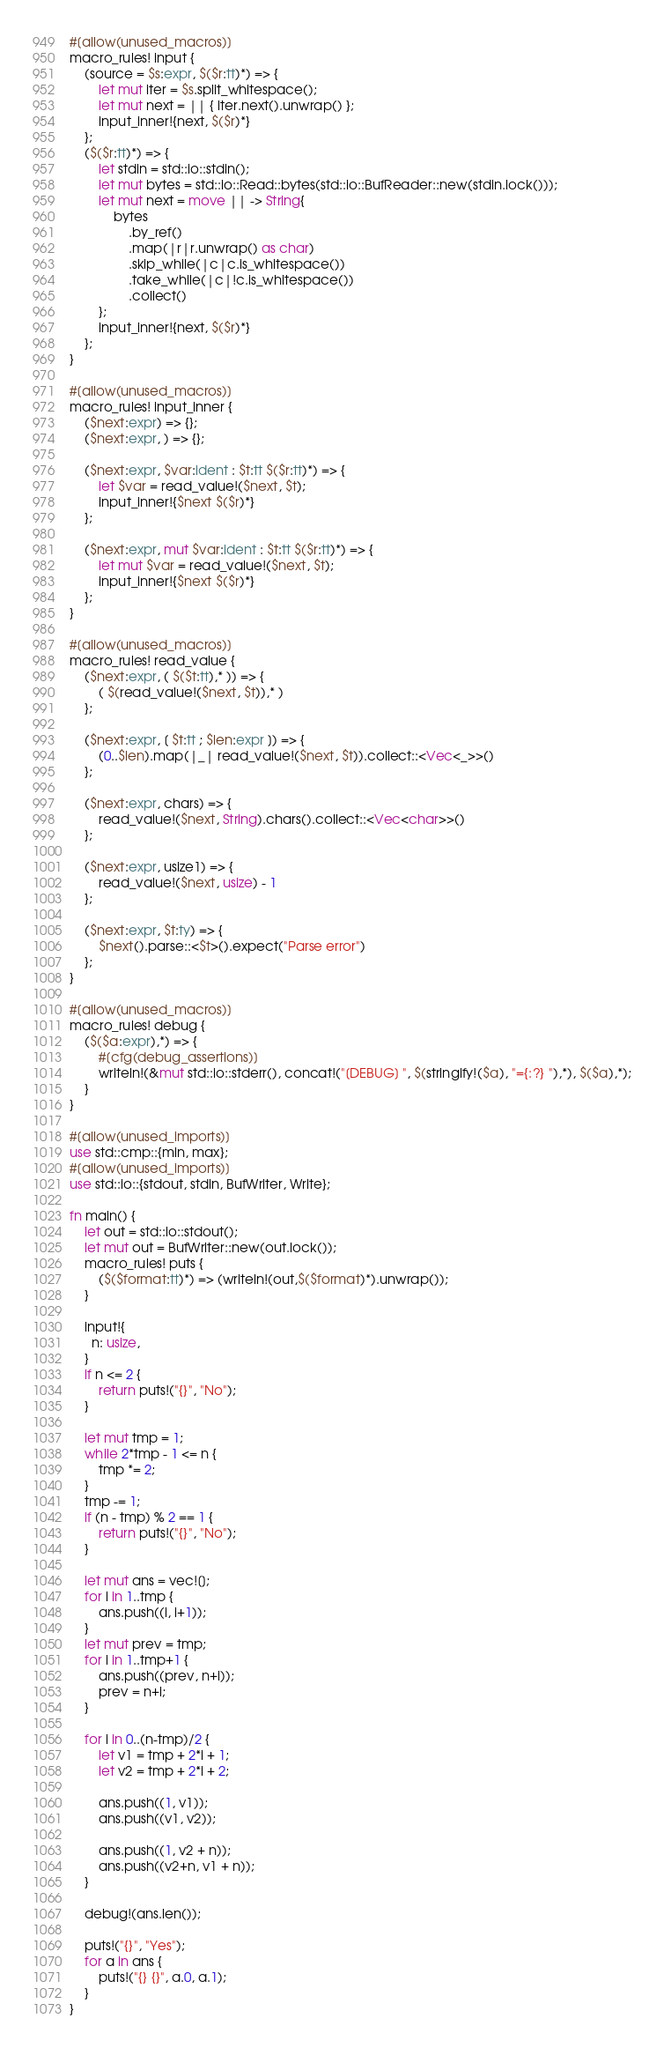<code> <loc_0><loc_0><loc_500><loc_500><_Rust_>#[allow(unused_macros)]
macro_rules! input {
    (source = $s:expr, $($r:tt)*) => {
        let mut iter = $s.split_whitespace();
        let mut next = || { iter.next().unwrap() };
        input_inner!{next, $($r)*}
    };
    ($($r:tt)*) => {
        let stdin = std::io::stdin();
        let mut bytes = std::io::Read::bytes(std::io::BufReader::new(stdin.lock()));
        let mut next = move || -> String{
            bytes
                .by_ref()
                .map(|r|r.unwrap() as char)
                .skip_while(|c|c.is_whitespace())
                .take_while(|c|!c.is_whitespace())
                .collect()
        };
        input_inner!{next, $($r)*}
    };
}

#[allow(unused_macros)]
macro_rules! input_inner {
    ($next:expr) => {};
    ($next:expr, ) => {};

    ($next:expr, $var:ident : $t:tt $($r:tt)*) => {
        let $var = read_value!($next, $t);
        input_inner!{$next $($r)*}
    };

    ($next:expr, mut $var:ident : $t:tt $($r:tt)*) => {
        let mut $var = read_value!($next, $t);
        input_inner!{$next $($r)*}
    };
}

#[allow(unused_macros)]
macro_rules! read_value {
    ($next:expr, ( $($t:tt),* )) => {
        ( $(read_value!($next, $t)),* )
    };

    ($next:expr, [ $t:tt ; $len:expr ]) => {
        (0..$len).map(|_| read_value!($next, $t)).collect::<Vec<_>>()
    };

    ($next:expr, chars) => {
        read_value!($next, String).chars().collect::<Vec<char>>()
    };

    ($next:expr, usize1) => {
        read_value!($next, usize) - 1
    };

    ($next:expr, $t:ty) => {
        $next().parse::<$t>().expect("Parse error")
    };
}

#[allow(unused_macros)]
macro_rules! debug {
    ($($a:expr),*) => {
        #[cfg(debug_assertions)]
        writeln!(&mut std::io::stderr(), concat!("[DEBUG] ", $(stringify!($a), "={:?} "),*), $($a),*);
    }
}

#[allow(unused_imports)]
use std::cmp::{min, max};
#[allow(unused_imports)]
use std::io::{stdout, stdin, BufWriter, Write};

fn main() {
    let out = std::io::stdout();
    let mut out = BufWriter::new(out.lock());
    macro_rules! puts {
        ($($format:tt)*) => (writeln!(out,$($format)*).unwrap());
    }

    input!{
      n: usize,
    }
    if n <= 2 {
        return puts!("{}", "No");
    }

    let mut tmp = 1;
    while 2*tmp - 1 <= n {
        tmp *= 2;
    }
    tmp -= 1;
    if (n - tmp) % 2 == 1 {
        return puts!("{}", "No");
    }

    let mut ans = vec![];
    for i in 1..tmp {
        ans.push((i, i+1));
    }
    let mut prev = tmp;
    for i in 1..tmp+1 {
        ans.push((prev, n+i));
        prev = n+i;
    }

    for i in 0..(n-tmp)/2 {
        let v1 = tmp + 2*i + 1;
        let v2 = tmp + 2*i + 2;

        ans.push((1, v1));
        ans.push((v1, v2));

        ans.push((1, v2 + n));
        ans.push((v2+n, v1 + n));
    }

    debug!(ans.len());

    puts!("{}", "Yes");
    for a in ans {
        puts!("{} {}", a.0, a.1);
    }
}
</code> 